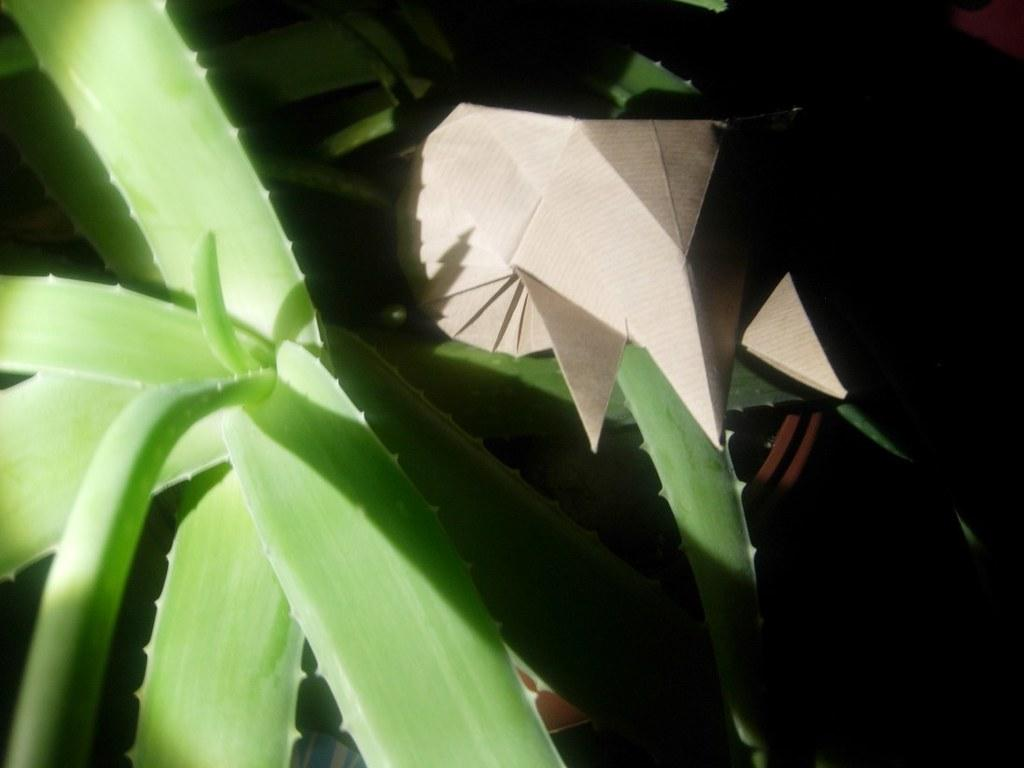What type of living organism can be seen in the image? There is a plant in the image. What is located in the flower pot with the plant? There is an object in the flower pot. How would you describe the overall lighting in the image? The background of the image is dark. What type of bed can be seen in the image? There is no bed present in the image; it features a plant in a flower pot with a dark background. 